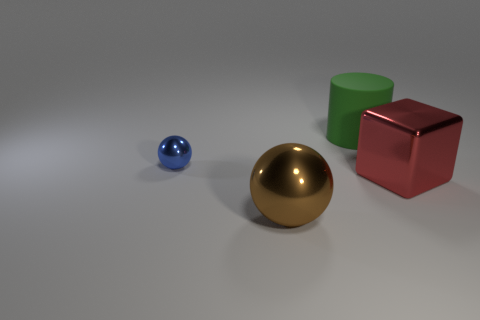Add 1 large gray metal blocks. How many objects exist? 5 Subtract all cubes. How many objects are left? 3 Subtract 0 brown cylinders. How many objects are left? 4 Subtract all large rubber things. Subtract all big cyan things. How many objects are left? 3 Add 1 large brown spheres. How many large brown spheres are left? 2 Add 2 large gray shiny blocks. How many large gray shiny blocks exist? 2 